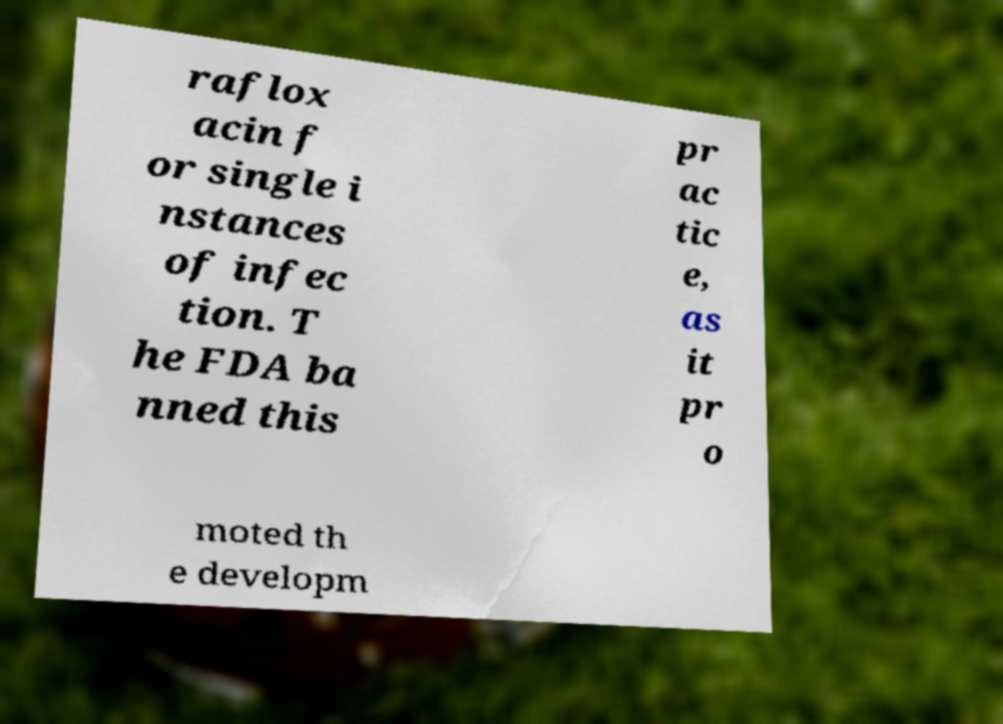Please identify and transcribe the text found in this image. raflox acin f or single i nstances of infec tion. T he FDA ba nned this pr ac tic e, as it pr o moted th e developm 